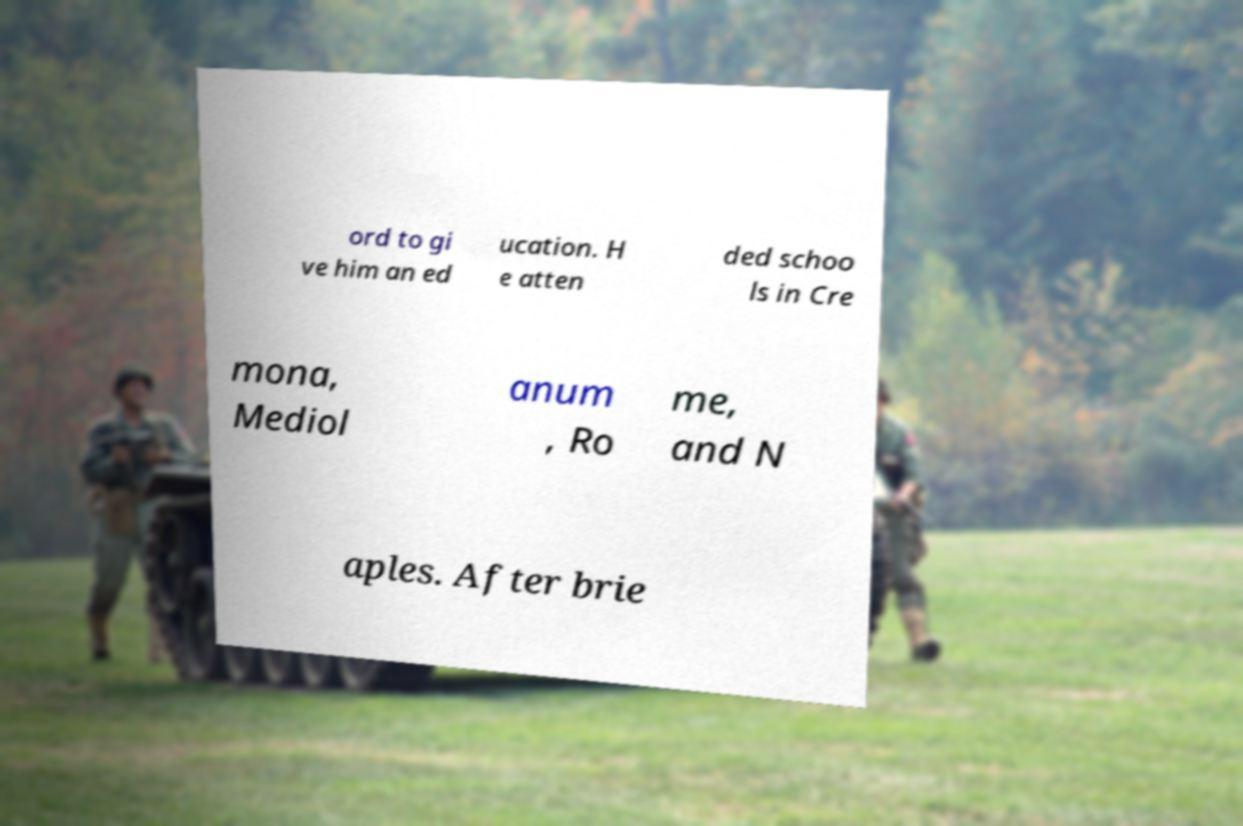What messages or text are displayed in this image? I need them in a readable, typed format. ord to gi ve him an ed ucation. H e atten ded schoo ls in Cre mona, Mediol anum , Ro me, and N aples. After brie 